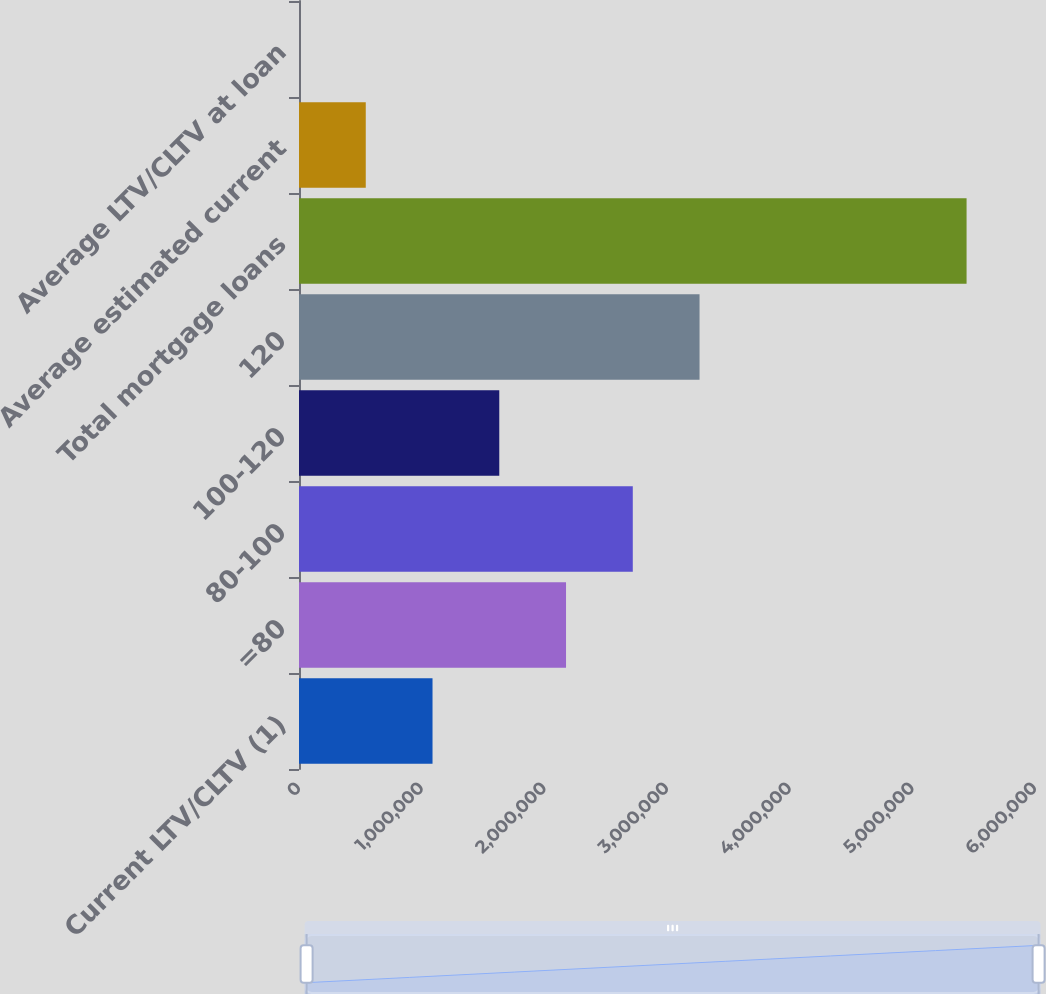Convert chart to OTSL. <chart><loc_0><loc_0><loc_500><loc_500><bar_chart><fcel>Current LTV/CLTV (1)<fcel>=80<fcel>80-100<fcel>100-120<fcel>120<fcel>Total mortgage loans<fcel>Average estimated current<fcel>Average LTV/CLTV at loan<nl><fcel>1.08849e+06<fcel>2.17691e+06<fcel>2.72112e+06<fcel>1.6327e+06<fcel>3.26533e+06<fcel>5.44217e+06<fcel>544281<fcel>71.2<nl></chart> 